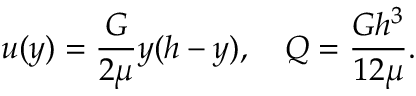<formula> <loc_0><loc_0><loc_500><loc_500>u ( y ) = { \frac { G } { 2 \mu } } y ( h - y ) , \quad Q = { \frac { G h ^ { 3 } } { 1 2 \mu } } .</formula> 